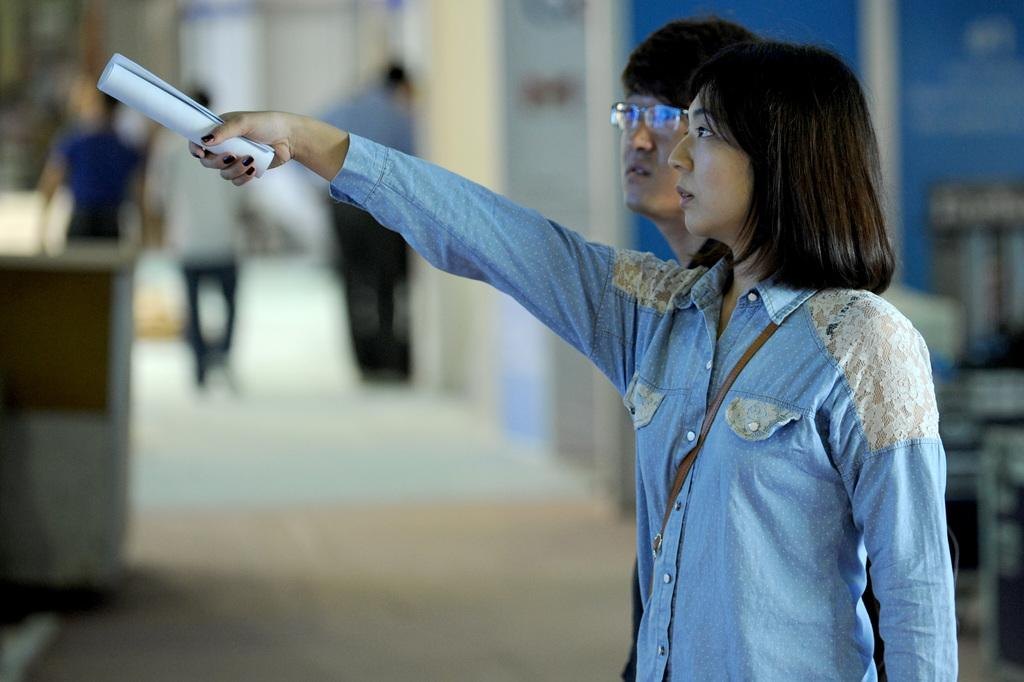How many people are in the image? There are people in the image, but the exact number is not specified. What is one person doing in the image? One person is holding an object in the image. What can be seen beneath the people in the image? The ground is visible in the image. What is the condition of the background in the image? The background of the image is blurred. What type of poison is being administered to the person in the image? There is no indication of poison or any medical situation in the image. 